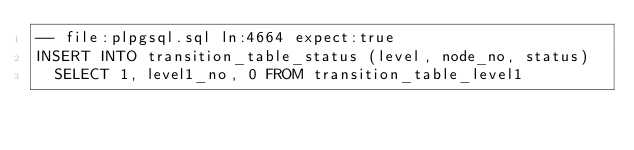Convert code to text. <code><loc_0><loc_0><loc_500><loc_500><_SQL_>-- file:plpgsql.sql ln:4664 expect:true
INSERT INTO transition_table_status (level, node_no, status)
  SELECT 1, level1_no, 0 FROM transition_table_level1
</code> 